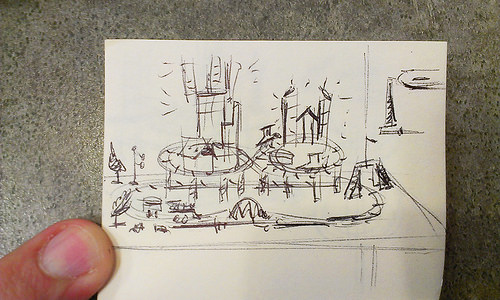<image>
Is the finger under the paper? No. The finger is not positioned under the paper. The vertical relationship between these objects is different. 